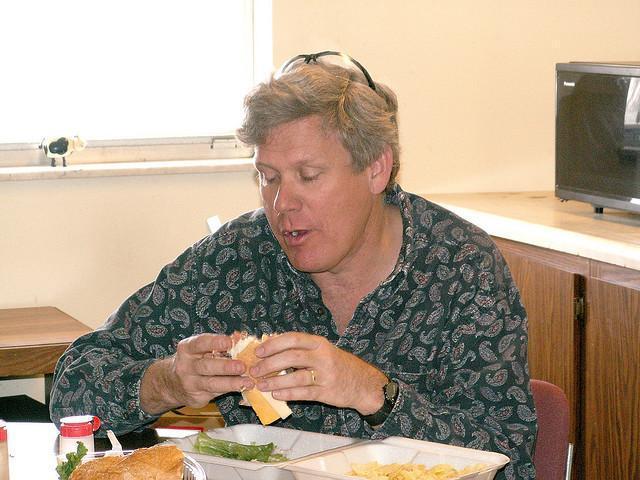How many dining tables are there?
Give a very brief answer. 2. How many sandwiches are visible?
Give a very brief answer. 2. 